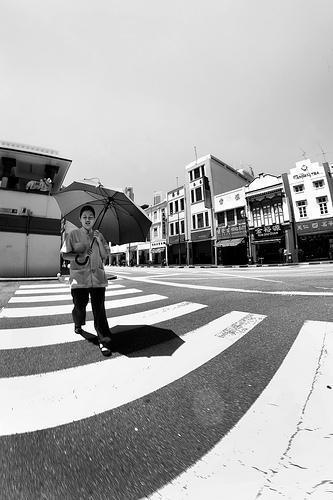How many people are seen?
Give a very brief answer. 1. How many cars are on the road?
Give a very brief answer. 0. 